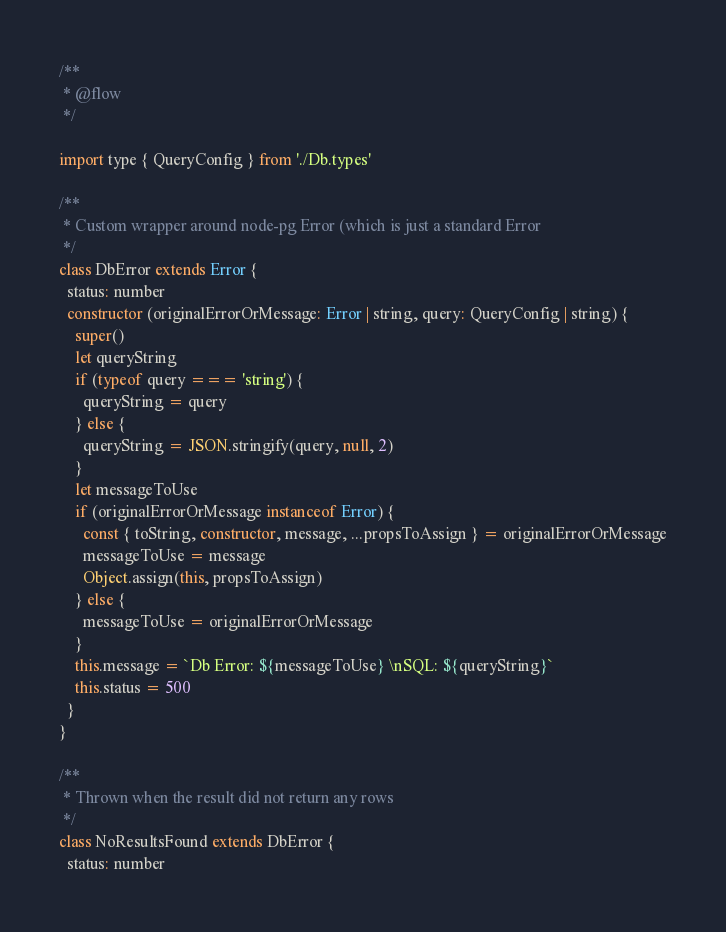Convert code to text. <code><loc_0><loc_0><loc_500><loc_500><_JavaScript_>/**
 * @flow
 */

import type { QueryConfig } from './Db.types'

/**
 * Custom wrapper around node-pg Error (which is just a standard Error
 */
class DbError extends Error {
  status: number
  constructor (originalErrorOrMessage: Error | string, query: QueryConfig | string) {
    super()
    let queryString
    if (typeof query === 'string') {
      queryString = query
    } else {
      queryString = JSON.stringify(query, null, 2)
    }
    let messageToUse
    if (originalErrorOrMessage instanceof Error) {
      const { toString, constructor, message, ...propsToAssign } = originalErrorOrMessage
      messageToUse = message
      Object.assign(this, propsToAssign)
    } else {
      messageToUse = originalErrorOrMessage
    }
    this.message = `Db Error: ${messageToUse} \nSQL: ${queryString}`
    this.status = 500
  }
}

/**
 * Thrown when the result did not return any rows
 */
class NoResultsFound extends DbError {
  status: number</code> 